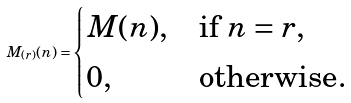<formula> <loc_0><loc_0><loc_500><loc_500>M _ { ( r ) } ( n ) = \begin{cases} M ( n ) , & \text {if $n = r$} , \\ 0 , & \text {otherwise} . \end{cases}</formula> 